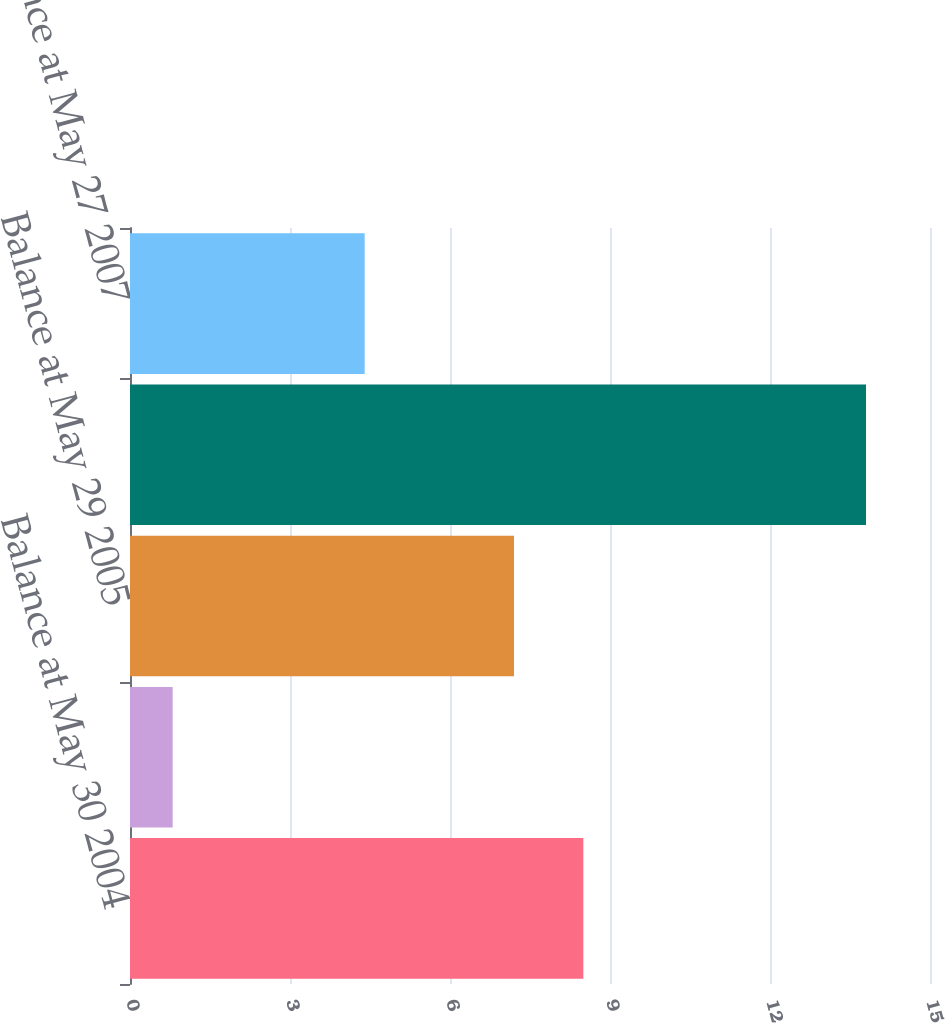Convert chart. <chart><loc_0><loc_0><loc_500><loc_500><bar_chart><fcel>Balance at May 30 2004<fcel>Current-period change<fcel>Balance at May 29 2005<fcel>Balance at May 28 2006<fcel>Balance at May 27 2007<nl><fcel>8.5<fcel>0.8<fcel>7.2<fcel>13.8<fcel>4.4<nl></chart> 